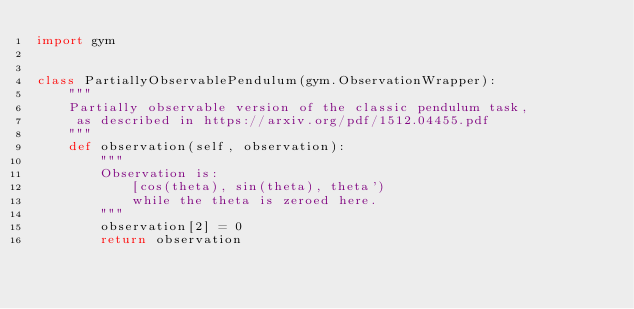<code> <loc_0><loc_0><loc_500><loc_500><_Python_>import gym


class PartiallyObservablePendulum(gym.ObservationWrapper):
    """
    Partially observable version of the classic pendulum task,
     as described in https://arxiv.org/pdf/1512.04455.pdf
    """
    def observation(self, observation):
        """
        Observation is:
            [cos(theta), sin(theta), theta')
            while the theta is zeroed here.
        """
        observation[2] = 0
        return observation

</code> 